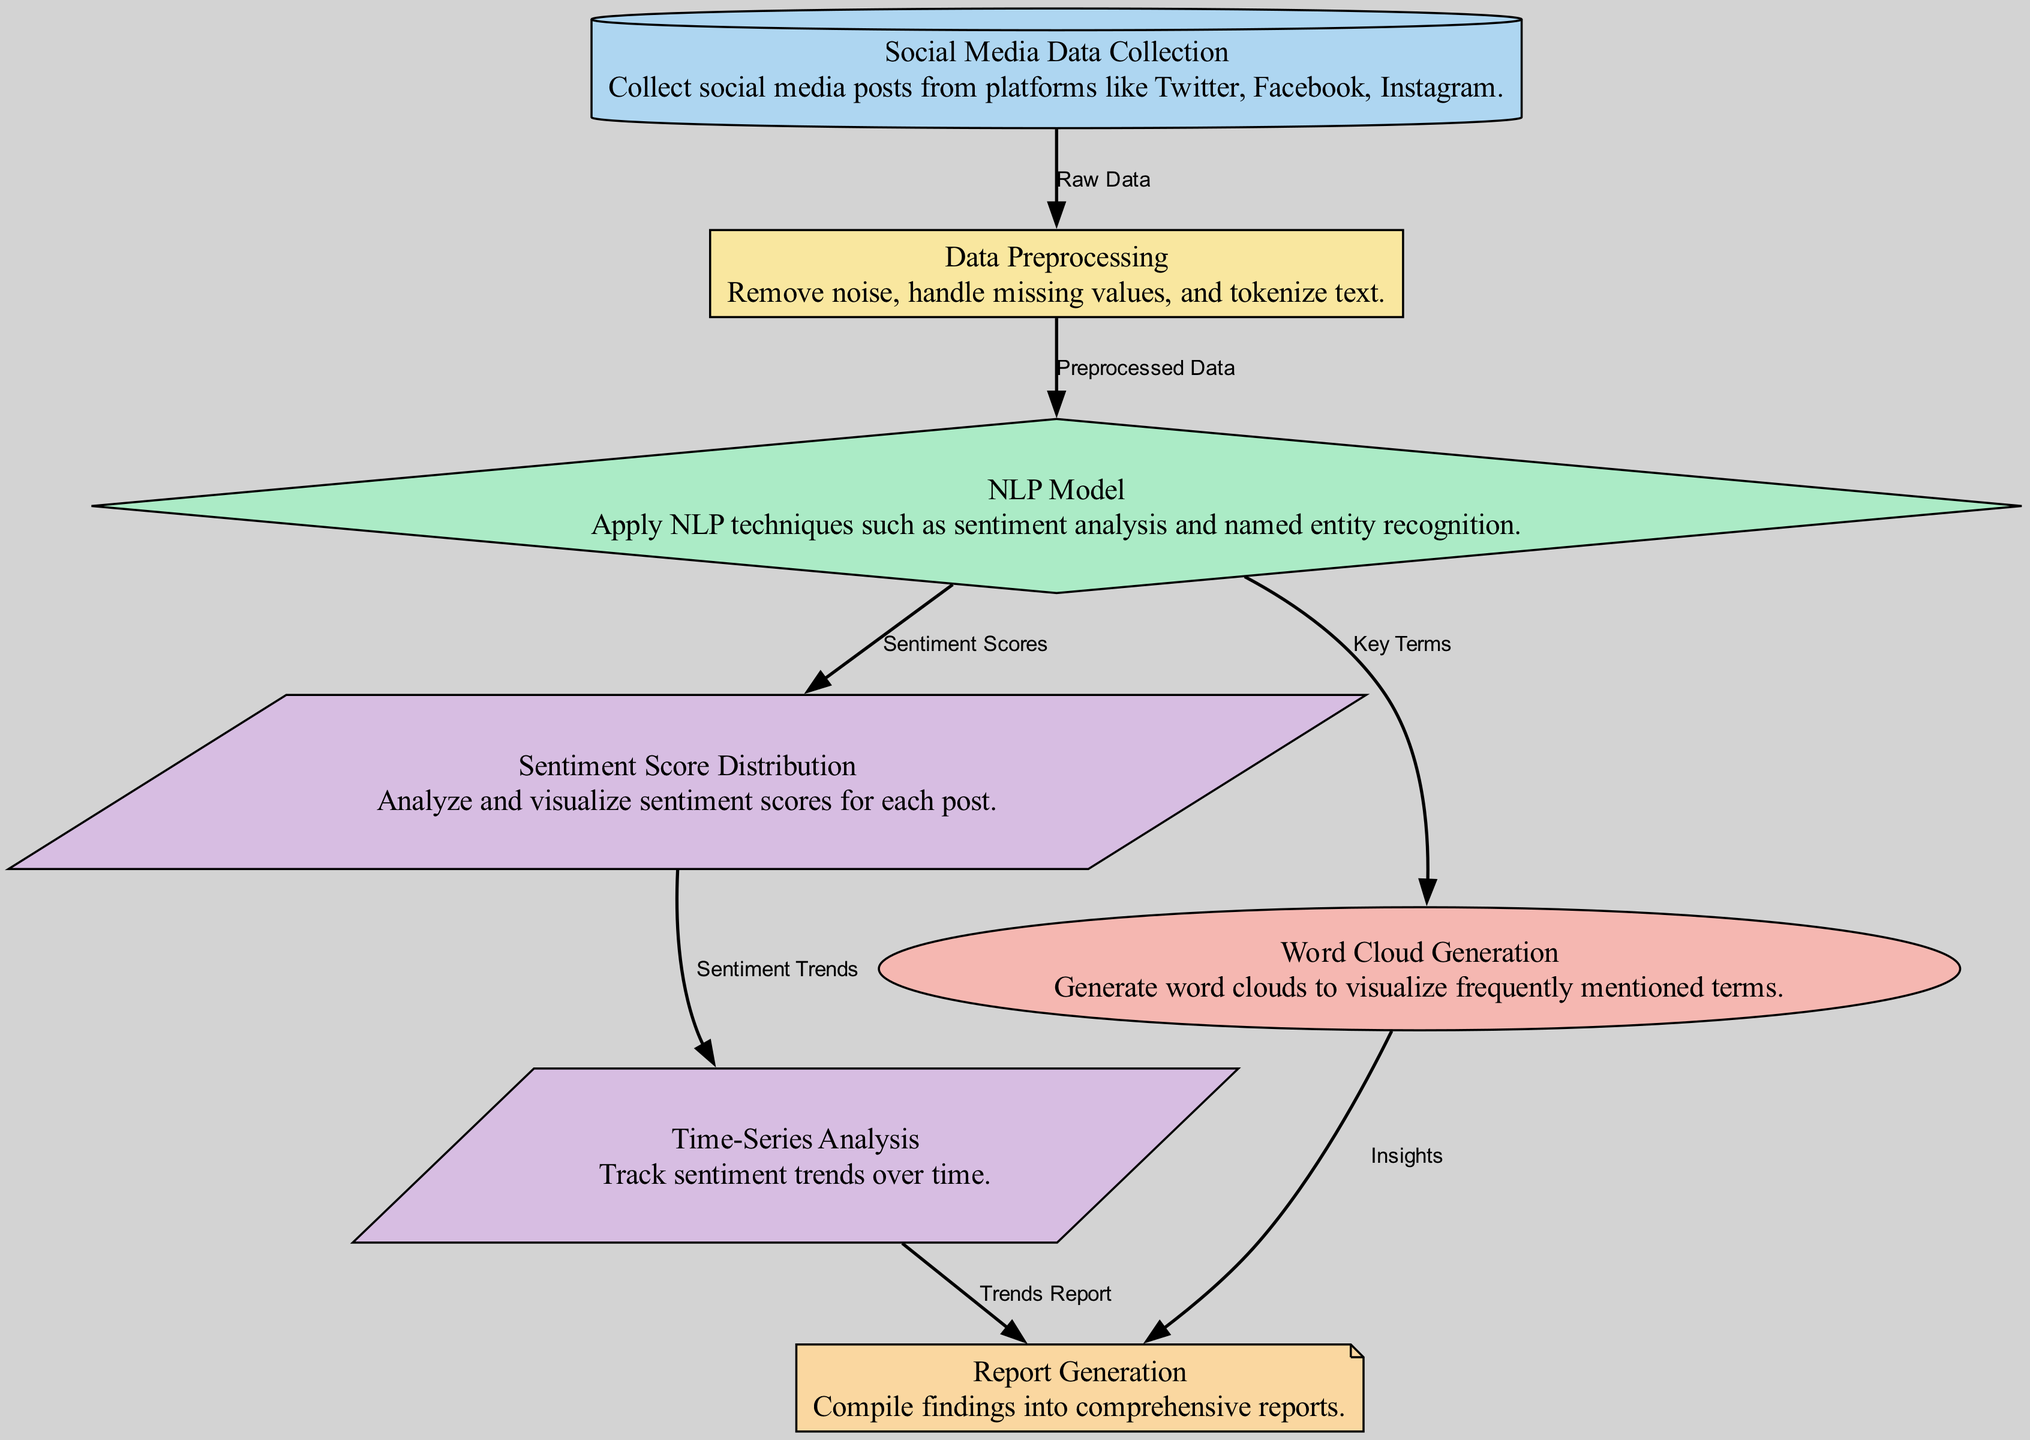What is the first step in the diagram? The first step is "Social Media Data Collection," which involves collecting social media posts from platforms like Twitter, Facebook, and Instagram.
Answer: Social Media Data Collection How many nodes are in the diagram? The diagram contains 7 nodes, each representing a different stage in the sentiment analysis process.
Answer: 7 What type of node is "NLP Model"? The "NLP Model" is a diamond-shaped node, indicating that it utilizes decision-making processes such as sentiment analysis and named entity recognition.
Answer: Diamond Which node analyzes sentiment scores for each post? The node that analyzes sentiment scores for each post is "Sentiment Score Distribution," which visualizes the sentiment scores derived from the NLP model.
Answer: Sentiment Score Distribution What relationship exists between the "NLP Model" and "Word Cloud Generation"? The relationship is that the "NLP Model" produces "Key Terms," which are then used in "Word Cloud Generation" for visualization of frequently mentioned terms.
Answer: Key Terms How does sentiment analysis data flow into report generation? The flow of data into report generation is from both "Word Cloud Generation," which provides insights, and "Time-Series Analysis," which offers trends report into the final "Report Generation" node.
Answer: Insights and Trends Report What type of analysis does the "Time-Series Analysis" node perform? The "Time-Series Analysis" node performs analysis that tracks sentiment trends over time by utilizing sentiment scores from previous nodes.
Answer: Track sentiment trends What does the "Data Preprocessing" node handle? The "Data Preprocessing" node handles the removal of noise, handling of missing values, and tokenization of text to prepare raw data for analysis.
Answer: Remove noise, handle missing values, and tokenize text What is the output of the "Sentiment Score Distribution" node? The output is visualized sentiment scores for each post, which helps gauge public sentiment on companies' sustainable practices.
Answer: Sentiment scores 